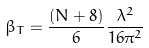Convert formula to latex. <formula><loc_0><loc_0><loc_500><loc_500>\beta _ { T } = \frac { ( N + 8 ) } { 6 } \frac { \lambda ^ { 2 } } { 1 6 \pi ^ { 2 } }</formula> 